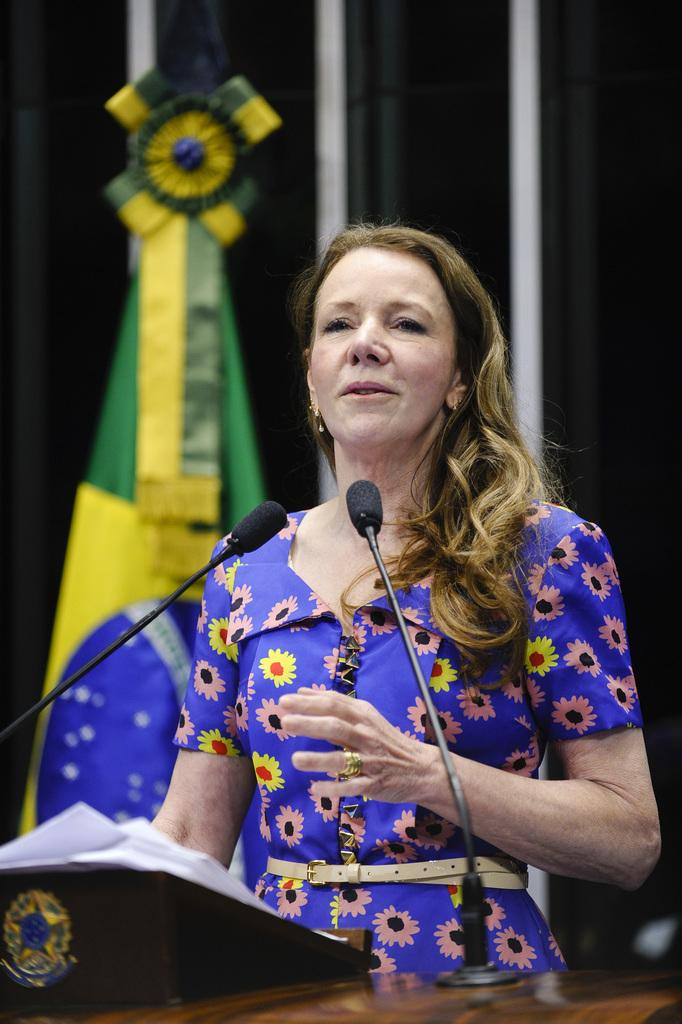Who is the main subject in the image? There is a woman in the image. Where is the woman located in relation to the image? The woman is standing in the foreground. What is the woman doing in the image? The woman appears to be speaking. What objects are in front of the woman? There are two microphones and papers in front of the woman. What can be seen in the background of the image? There is a flag visible in the background. What type of flower is the woman holding in her mouth in the image? There is no flower or mouth visible in the image; the woman appears to be speaking into microphones. 